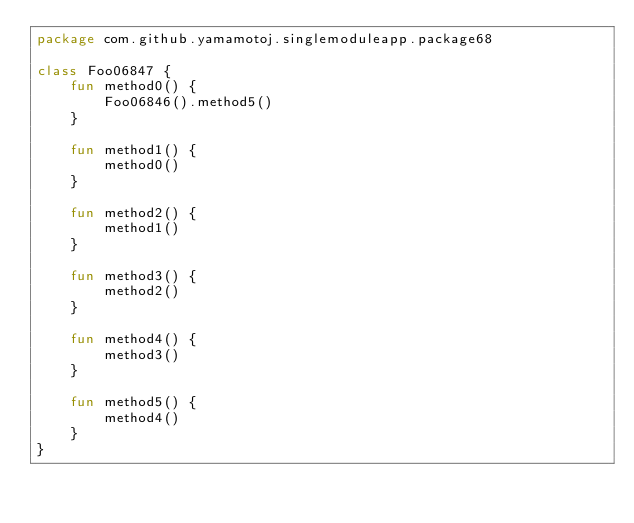<code> <loc_0><loc_0><loc_500><loc_500><_Kotlin_>package com.github.yamamotoj.singlemoduleapp.package68

class Foo06847 {
    fun method0() {
        Foo06846().method5()
    }

    fun method1() {
        method0()
    }

    fun method2() {
        method1()
    }

    fun method3() {
        method2()
    }

    fun method4() {
        method3()
    }

    fun method5() {
        method4()
    }
}
</code> 